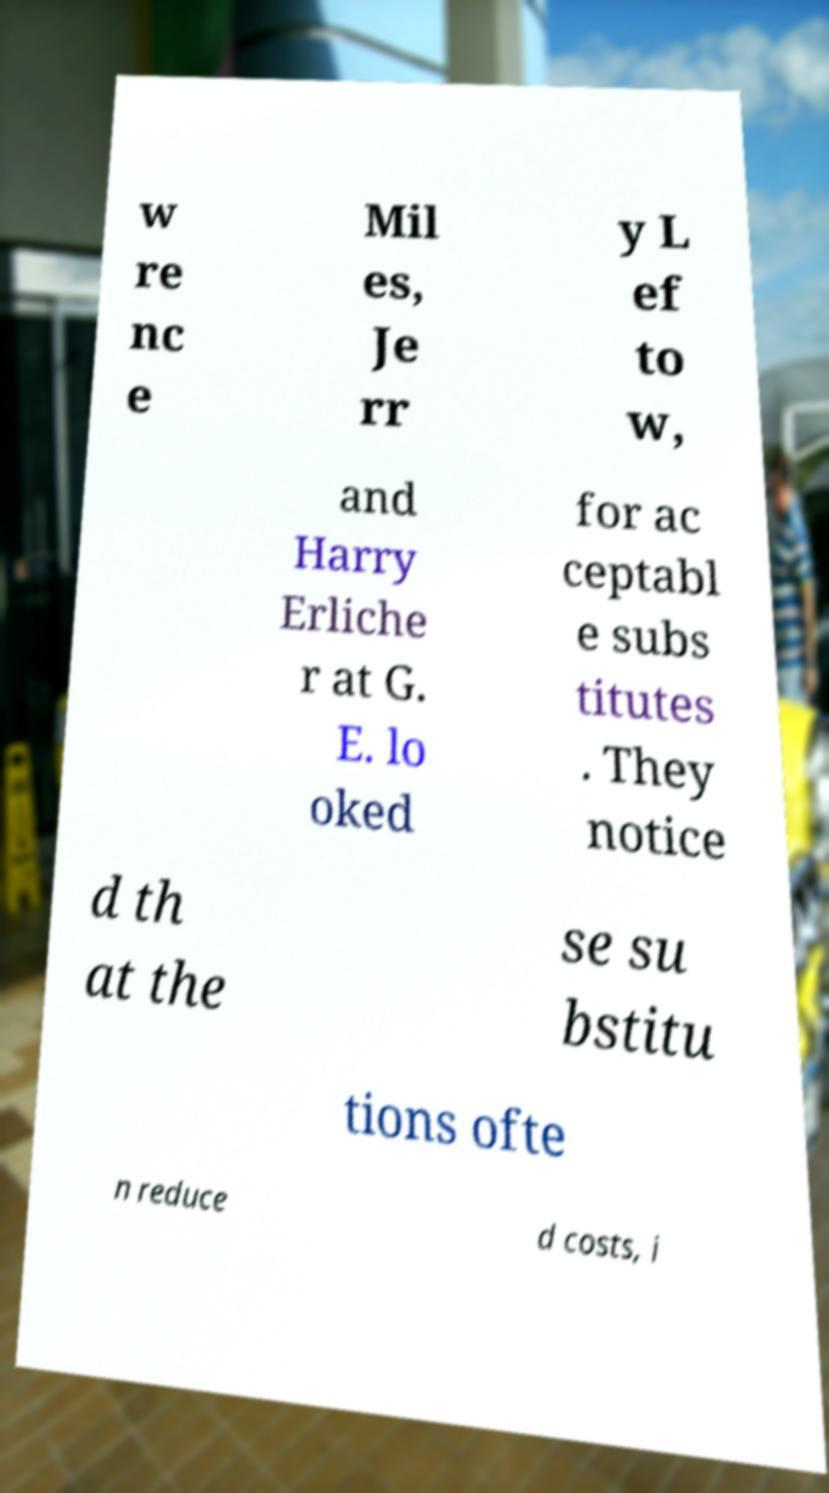Please read and relay the text visible in this image. What does it say? w re nc e Mil es, Je rr y L ef to w, and Harry Erliche r at G. E. lo oked for ac ceptabl e subs titutes . They notice d th at the se su bstitu tions ofte n reduce d costs, i 